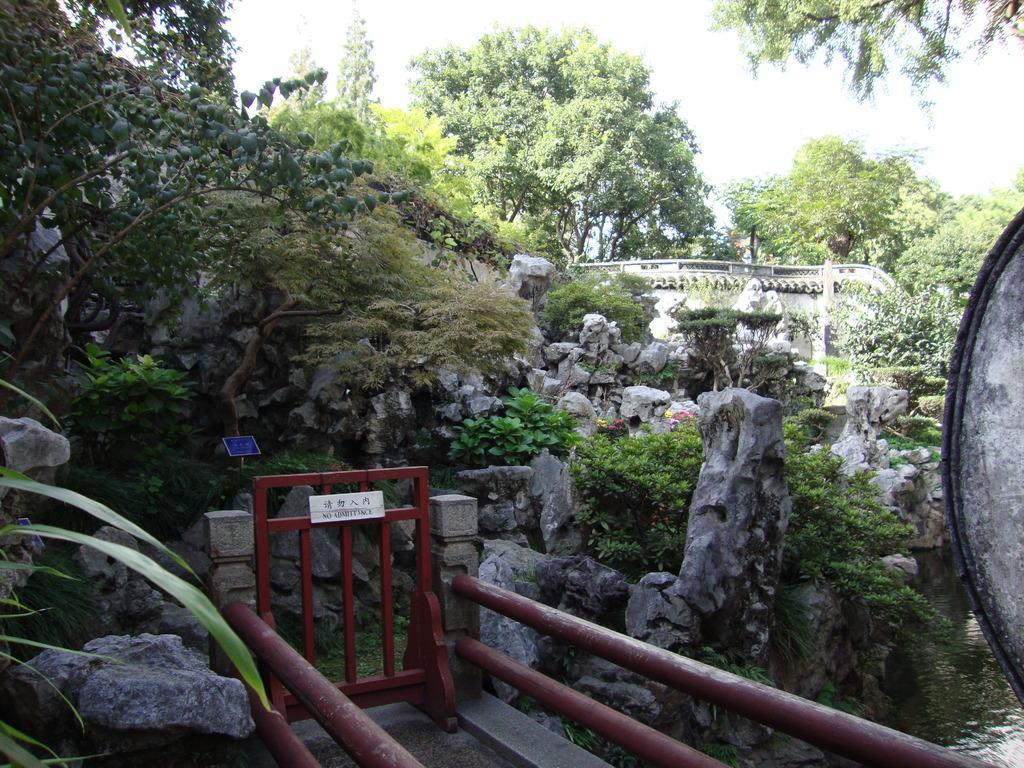Can you describe this image briefly? In this picture I can see there is a handrail, a gate and there are few plants, rocks, trees and there is a wall at right side and the sky is clear. 